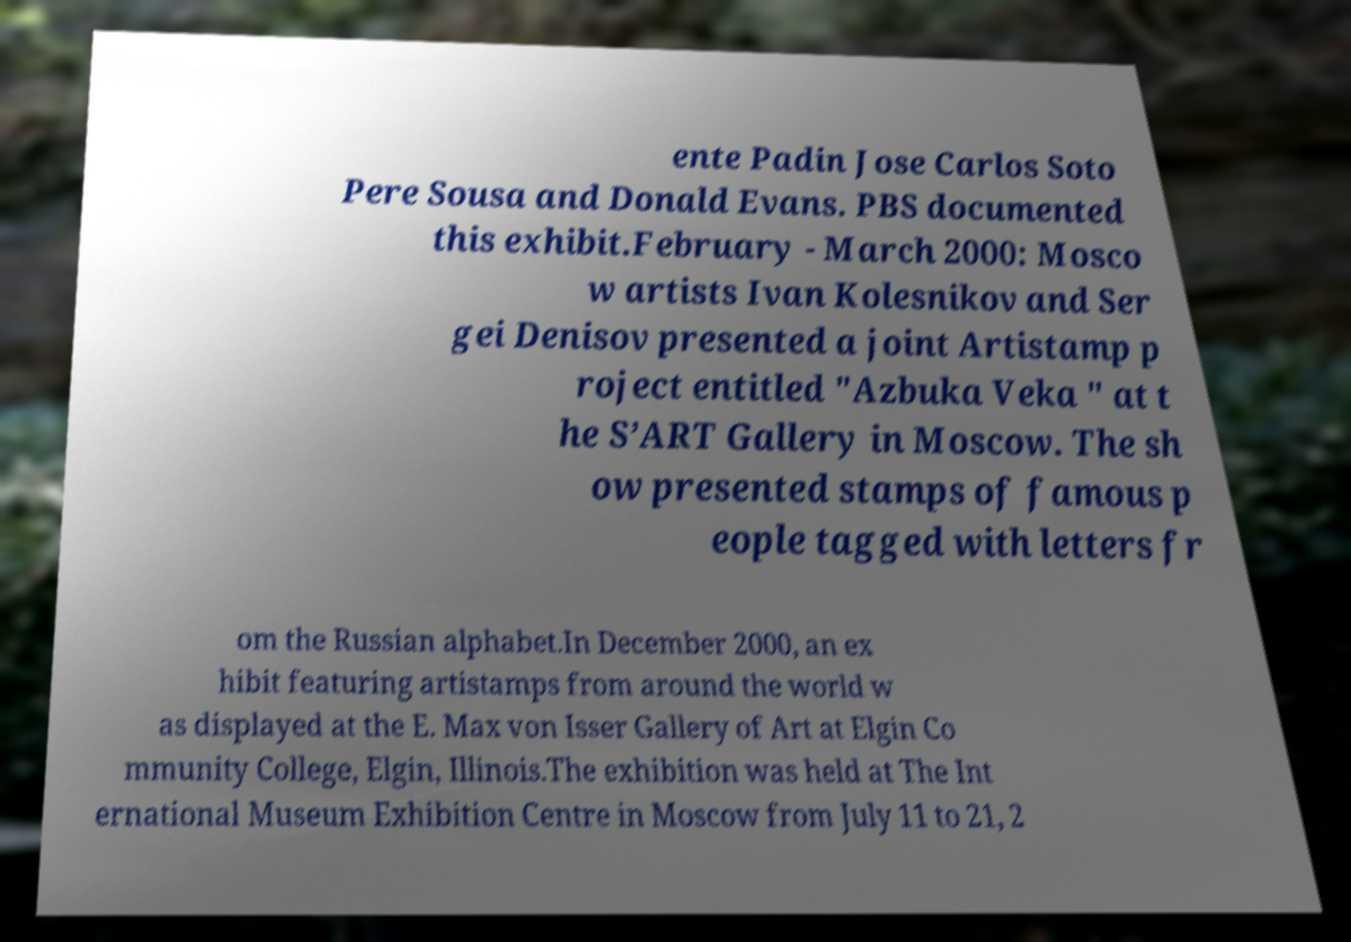There's text embedded in this image that I need extracted. Can you transcribe it verbatim? ente Padin Jose Carlos Soto Pere Sousa and Donald Evans. PBS documented this exhibit.February - March 2000: Mosco w artists Ivan Kolesnikov and Ser gei Denisov presented a joint Artistamp p roject entitled "Azbuka Veka " at t he S’ART Gallery in Moscow. The sh ow presented stamps of famous p eople tagged with letters fr om the Russian alphabet.In December 2000, an ex hibit featuring artistamps from around the world w as displayed at the E. Max von Isser Gallery of Art at Elgin Co mmunity College, Elgin, Illinois.The exhibition was held at The Int ernational Museum Exhibition Centre in Moscow from July 11 to 21, 2 